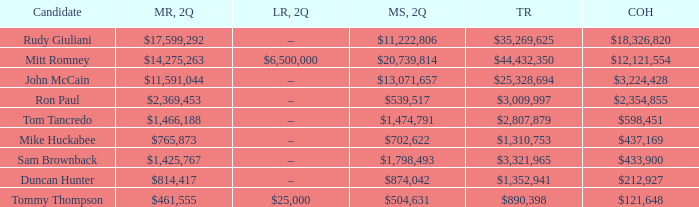Give me the full table as a dictionary. {'header': ['Candidate', 'MR, 2Q', 'LR, 2Q', 'MS, 2Q', 'TR', 'COH'], 'rows': [['Rudy Giuliani', '$17,599,292', '–', '$11,222,806', '$35,269,625', '$18,326,820'], ['Mitt Romney', '$14,275,263', '$6,500,000', '$20,739,814', '$44,432,350', '$12,121,554'], ['John McCain', '$11,591,044', '–', '$13,071,657', '$25,328,694', '$3,224,428'], ['Ron Paul', '$2,369,453', '–', '$539,517', '$3,009,997', '$2,354,855'], ['Tom Tancredo', '$1,466,188', '–', '$1,474,791', '$2,807,879', '$598,451'], ['Mike Huckabee', '$765,873', '–', '$702,622', '$1,310,753', '$437,169'], ['Sam Brownback', '$1,425,767', '–', '$1,798,493', '$3,321,965', '$433,900'], ['Duncan Hunter', '$814,417', '–', '$874,042', '$1,352,941', '$212,927'], ['Tommy Thompson', '$461,555', '$25,000', '$504,631', '$890,398', '$121,648']]} Name the loans received for 2Q having total receipts of $25,328,694 –. 